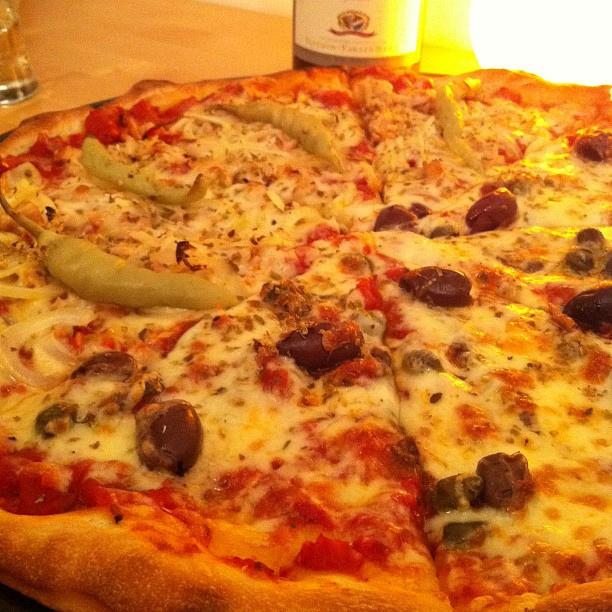Where is the pizza?
Be succinct. On table. What snack is seen?
Answer briefly. Pizza. Is this pizza cut or whole?
Short answer required. Cut. Is this a traditional pizza?
Answer briefly. Yes. What toppings are on the pizza?
Keep it brief. Sausage. 